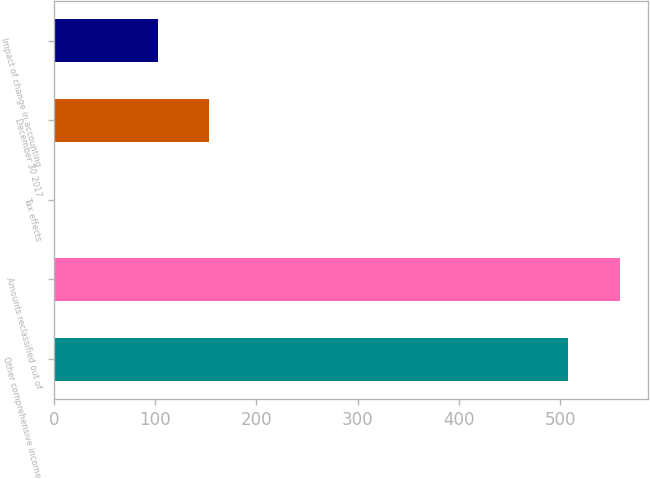<chart> <loc_0><loc_0><loc_500><loc_500><bar_chart><fcel>Other comprehensive income<fcel>Amounts reclassified out of<fcel>Tax effects<fcel>December 30 2017<fcel>Impact of change in accounting<nl><fcel>508<fcel>558.8<fcel>1<fcel>153.4<fcel>102.6<nl></chart> 